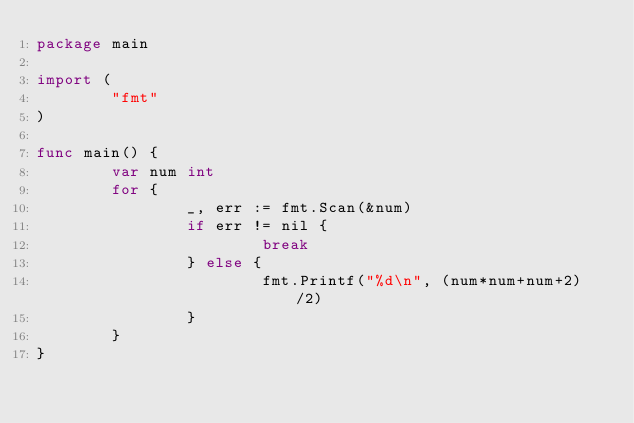Convert code to text. <code><loc_0><loc_0><loc_500><loc_500><_Go_>package main

import (
        "fmt"
)

func main() {
        var num int
        for {
                _, err := fmt.Scan(&num)
                if err != nil {
                        break
                } else {
                        fmt.Printf("%d\n", (num*num+num+2)/2)
                }
        }
}
</code> 